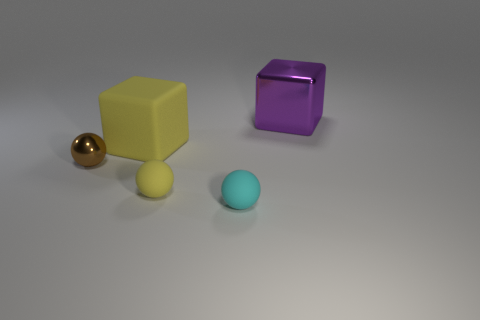Can you describe the colors of each large object in the image? Sure! There's a large, shiny yellow cube and a larger, shiny purple block. The yellow cube displays a matte-like finish, while the purple one has a reflective surface. 